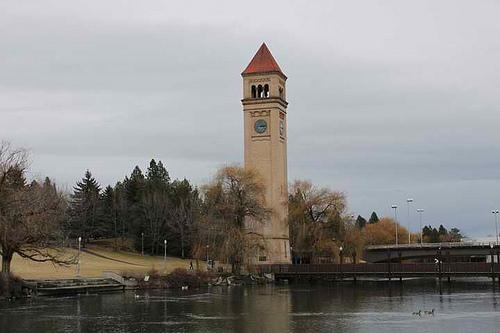Question: what is the time?
Choices:
A. 4:15 pm.
B. 3:15 pm.
C. 2:15 pm.
D. 3:15 am.
Answer with the letter. Answer: B Question: why is the clock there?
Choices:
A. To freeze the time.
B. To display the time.
C. To change the battery.
D. To change the time.
Answer with the letter. Answer: B 